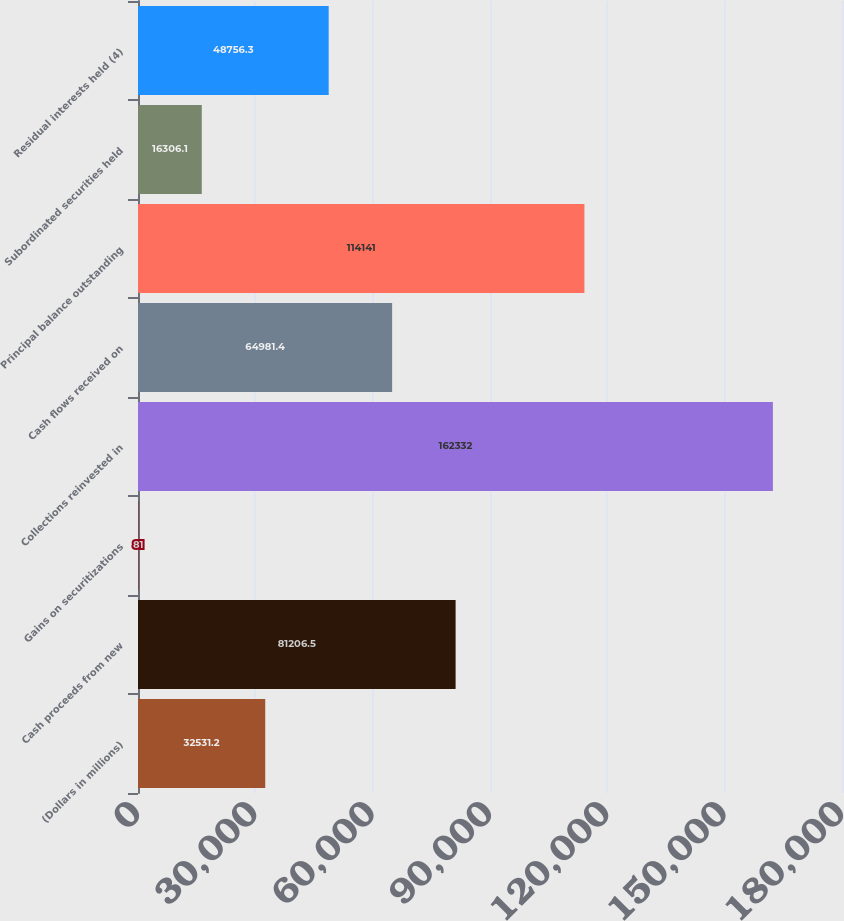<chart> <loc_0><loc_0><loc_500><loc_500><bar_chart><fcel>(Dollars in millions)<fcel>Cash proceeds from new<fcel>Gains on securitizations<fcel>Collections reinvested in<fcel>Cash flows received on<fcel>Principal balance outstanding<fcel>Subordinated securities held<fcel>Residual interests held (4)<nl><fcel>32531.2<fcel>81206.5<fcel>81<fcel>162332<fcel>64981.4<fcel>114141<fcel>16306.1<fcel>48756.3<nl></chart> 